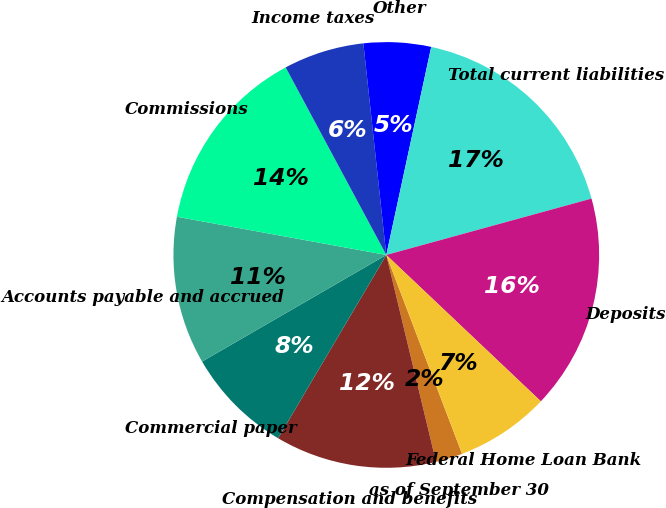Convert chart. <chart><loc_0><loc_0><loc_500><loc_500><pie_chart><fcel>as of September 30<fcel>Compensation and benefits<fcel>Commercial paper<fcel>Accounts payable and accrued<fcel>Commissions<fcel>Income taxes<fcel>Other<fcel>Total current liabilities<fcel>Deposits<fcel>Federal Home Loan Bank<nl><fcel>2.04%<fcel>12.24%<fcel>8.16%<fcel>11.22%<fcel>14.29%<fcel>6.12%<fcel>5.1%<fcel>17.35%<fcel>16.33%<fcel>7.14%<nl></chart> 